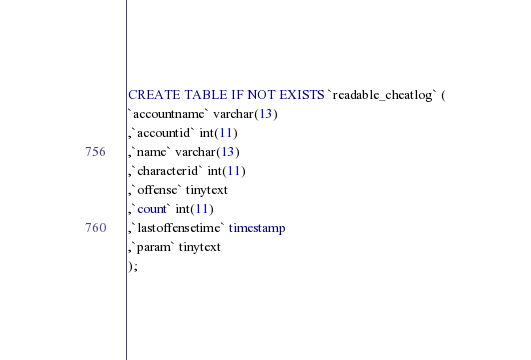Convert code to text. <code><loc_0><loc_0><loc_500><loc_500><_SQL_>CREATE TABLE IF NOT EXISTS `readable_cheatlog` (
`accountname` varchar(13)
,`accountid` int(11)
,`name` varchar(13)
,`characterid` int(11)
,`offense` tinytext
,`count` int(11)
,`lastoffensetime` timestamp
,`param` tinytext
);</code> 